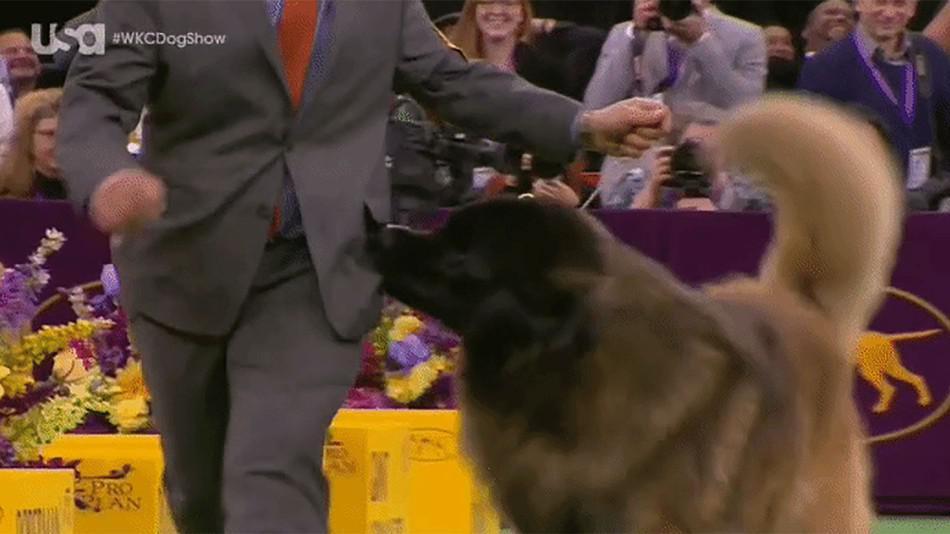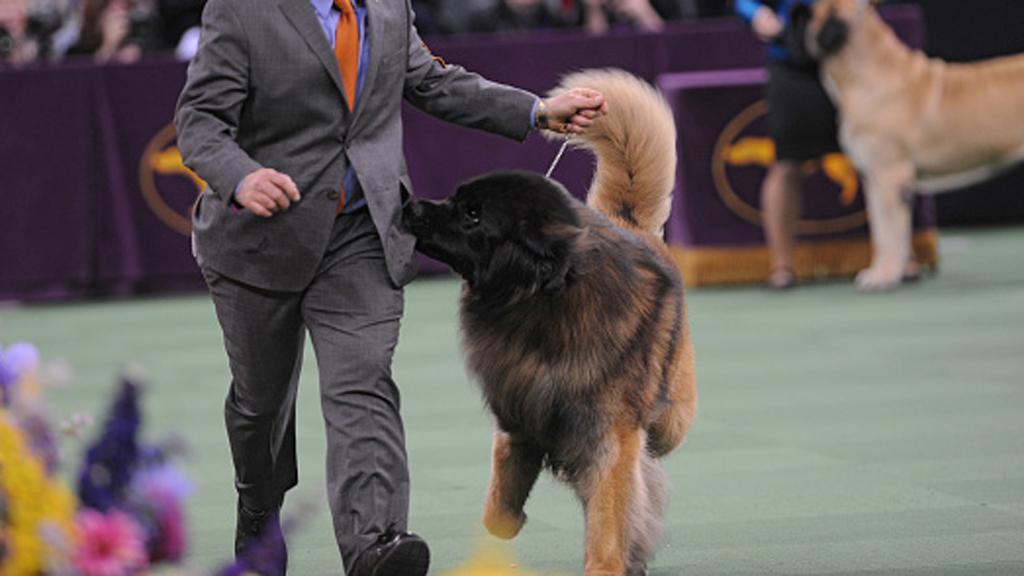The first image is the image on the left, the second image is the image on the right. Examine the images to the left and right. Is the description "There are more than two dogs visible." accurate? Answer yes or no. Yes. The first image is the image on the left, the second image is the image on the right. For the images displayed, is the sentence "Exactly one image, the one on the left, shows a dog tugging on the pocket of its handler at a dog show, and the handler is wearing a brownish-yellow necktie." factually correct? Answer yes or no. No. 